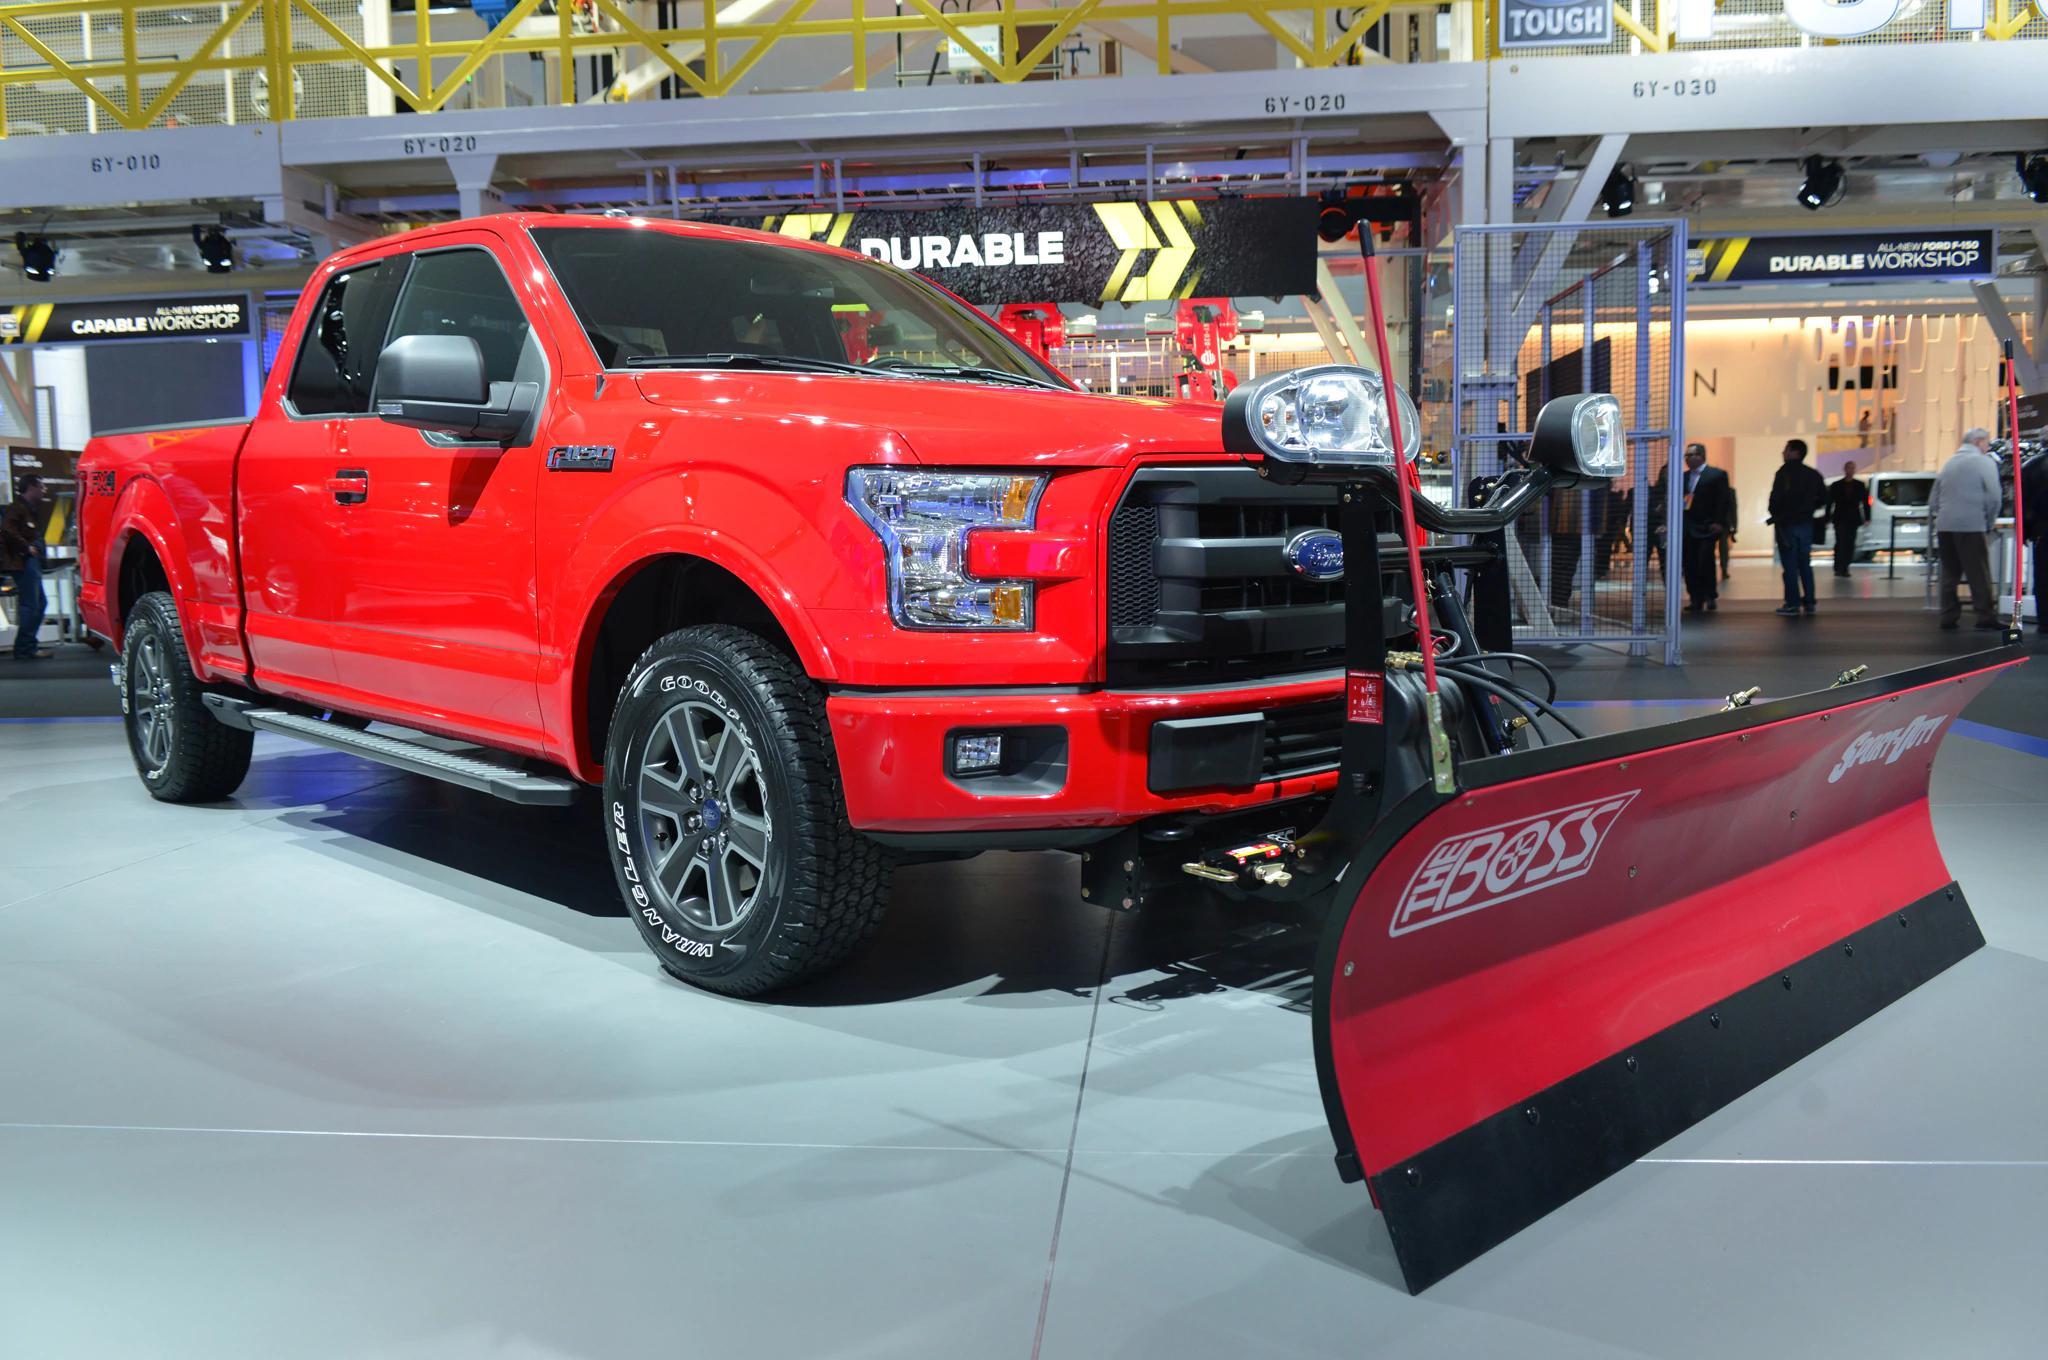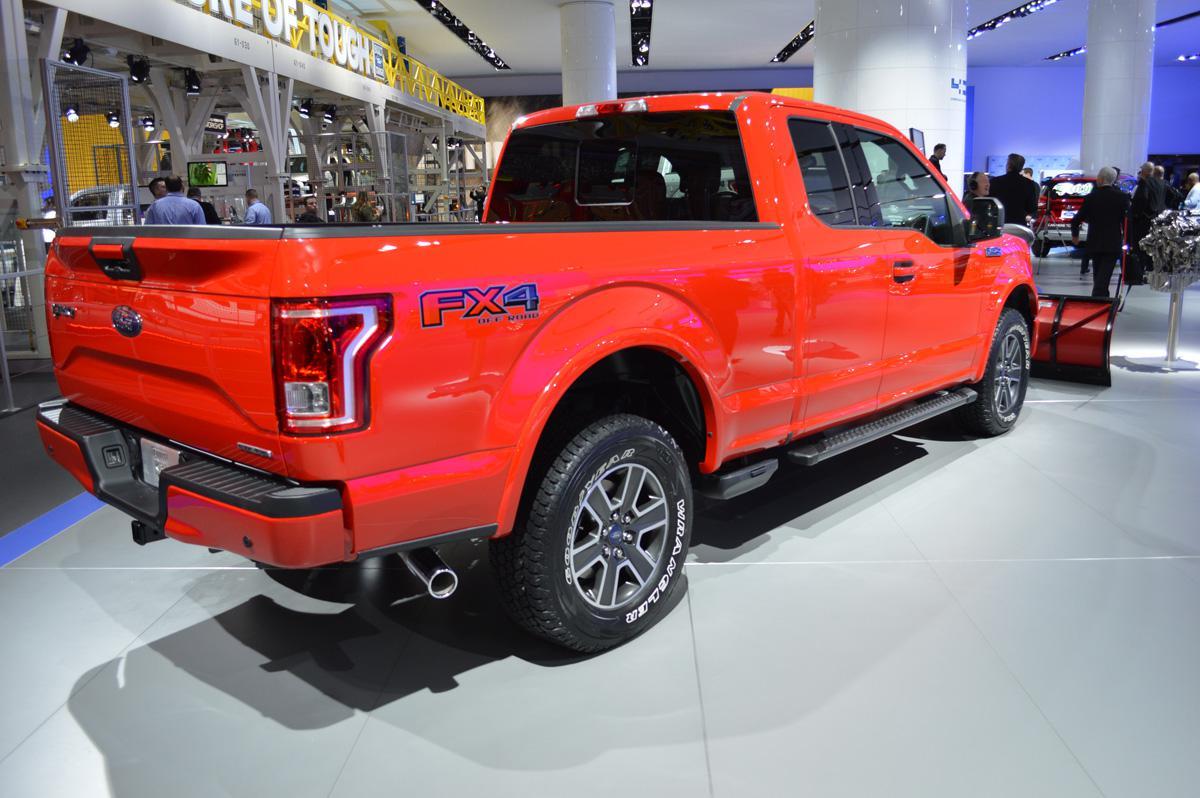The first image is the image on the left, the second image is the image on the right. Assess this claim about the two images: "Right image shows a red truck with its plow pushing up snow.". Correct or not? Answer yes or no. No. The first image is the image on the left, the second image is the image on the right. For the images displayed, is the sentence "One or more of the plows shown are pushing snow." factually correct? Answer yes or no. No. 